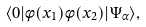<formula> <loc_0><loc_0><loc_500><loc_500>\langle 0 | \phi ( x _ { 1 } ) \phi ( x _ { 2 } ) | \Psi _ { \alpha } \rangle ,</formula> 